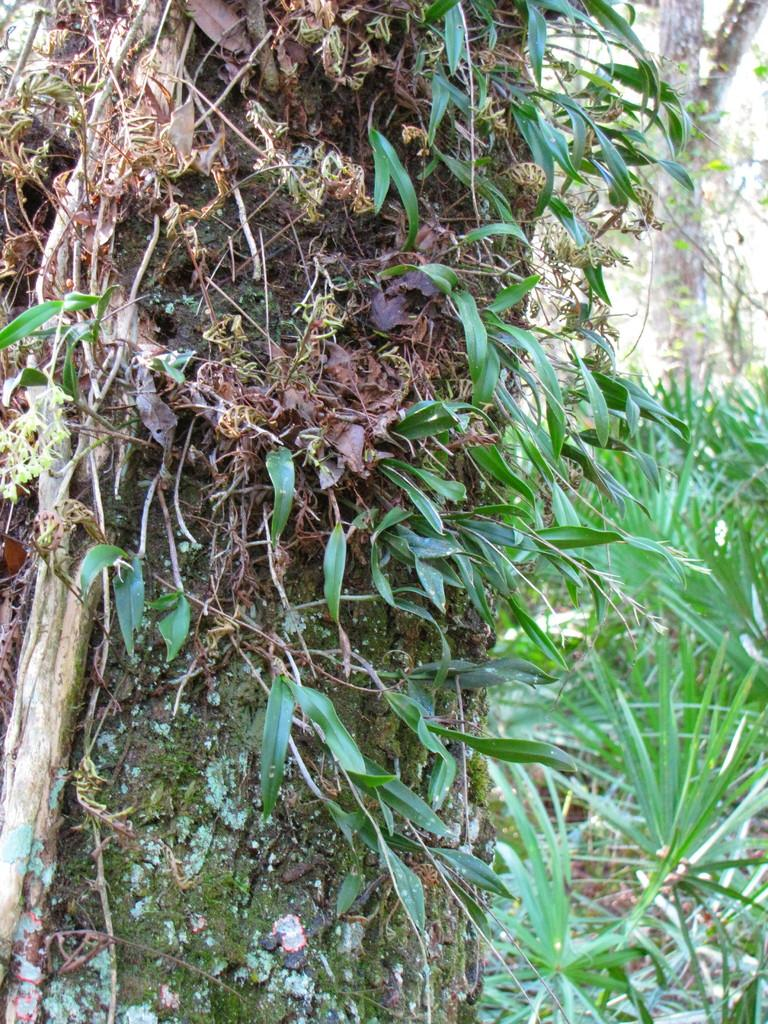What type of natural elements can be seen in the image? There are tree trunks, leaves, and plants in the image. Can you describe the tree trunks in the image? The tree trunks in the image are the main stems of trees, providing support and structure. What else can be found among the tree trunks and leaves? There are also plants visible in the image. Where is the throne located in the image? There is no throne present in the image. Can you describe the kiss between the two leaves in the image? There are no leaves or any other elements in the image that could be interpreted as engaging in a kiss. 